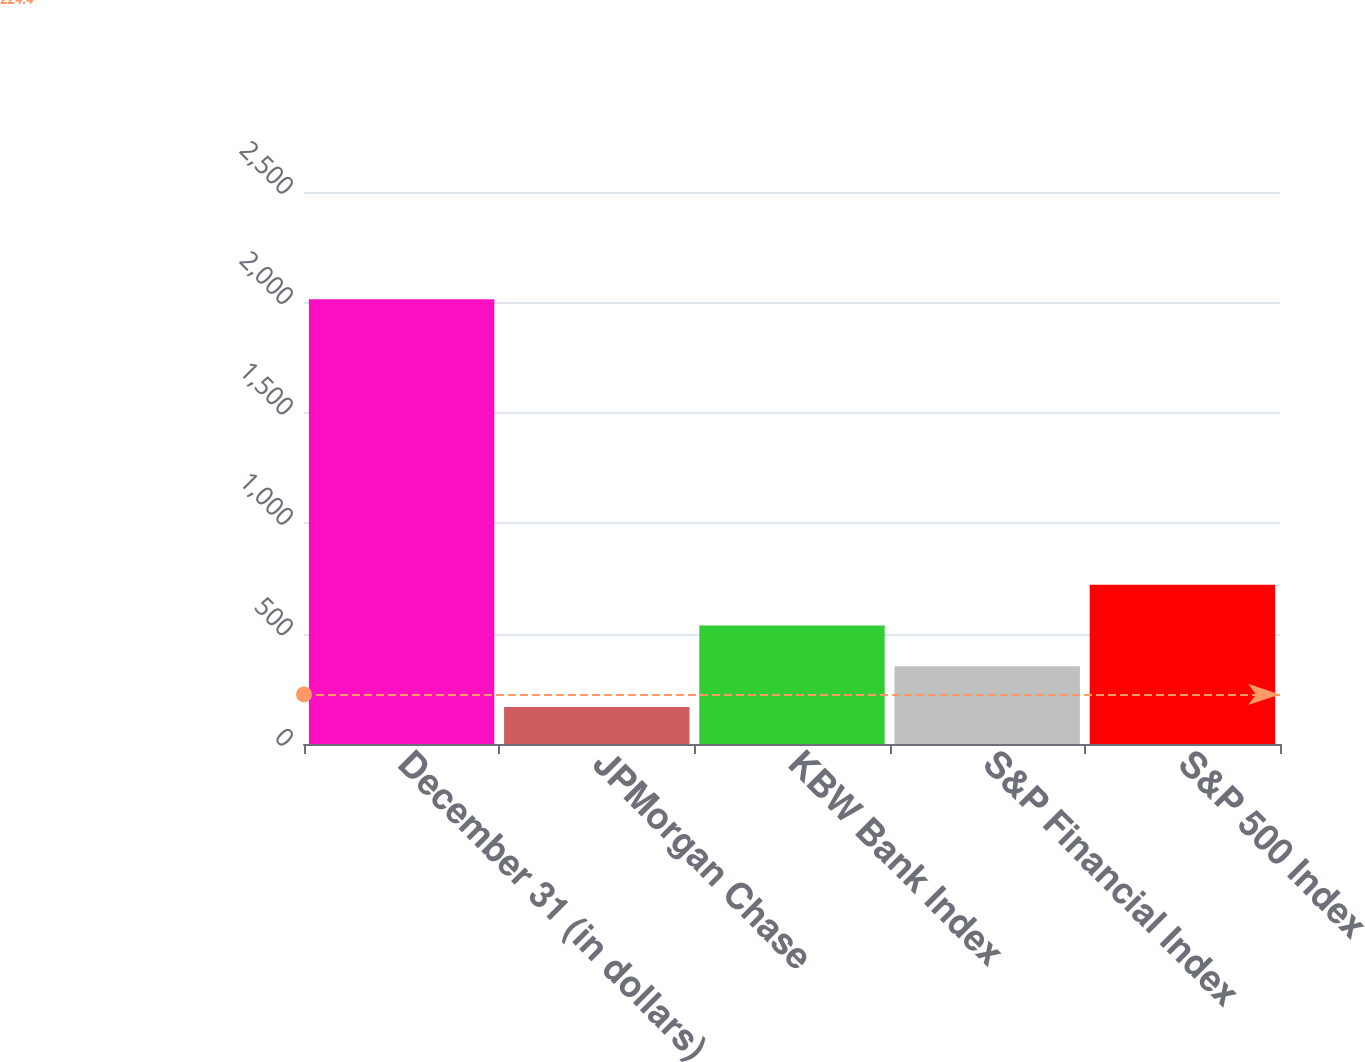Convert chart to OTSL. <chart><loc_0><loc_0><loc_500><loc_500><bar_chart><fcel>December 31 (in dollars)<fcel>JPMorgan Chase<fcel>KBW Bank Index<fcel>S&P Financial Index<fcel>S&P 500 Index<nl><fcel>2014<fcel>167.48<fcel>536.78<fcel>352.13<fcel>721.43<nl></chart> 